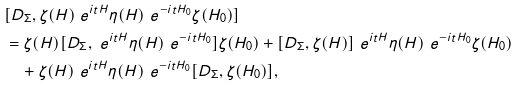Convert formula to latex. <formula><loc_0><loc_0><loc_500><loc_500>& [ D _ { \Sigma } , \zeta ( H ) \ e ^ { i t H } \eta ( H ) \ e ^ { - i t H _ { 0 } } \zeta ( H _ { 0 } ) ] \\ & = \zeta ( H ) [ D _ { \Sigma } , \ e ^ { i t H } \eta ( H ) \ e ^ { - i t H _ { 0 } } ] \zeta ( H _ { 0 } ) + [ D _ { \Sigma } , \zeta ( H ) ] \ e ^ { i t H } \eta ( H ) \ e ^ { - i t H _ { 0 } } \zeta ( H _ { 0 } ) \\ & \quad + \zeta ( H ) \ e ^ { i t H } \eta ( H ) \ e ^ { - i t H _ { 0 } } [ D _ { \Sigma } , \zeta ( H _ { 0 } ) ] ,</formula> 